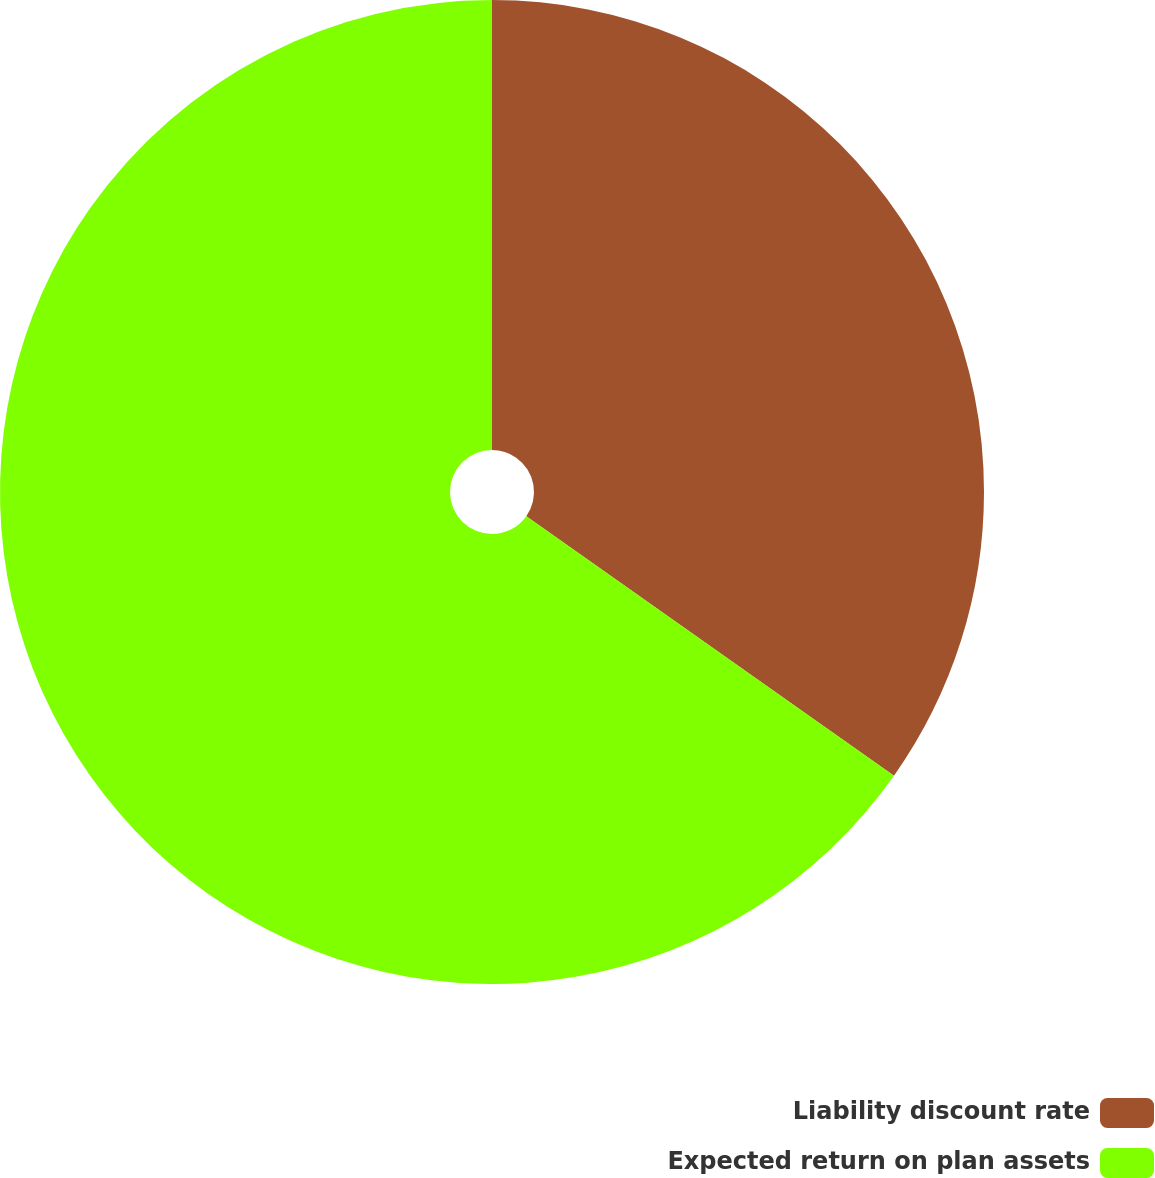<chart> <loc_0><loc_0><loc_500><loc_500><pie_chart><fcel>Liability discount rate<fcel>Expected return on plan assets<nl><fcel>34.78%<fcel>65.22%<nl></chart> 